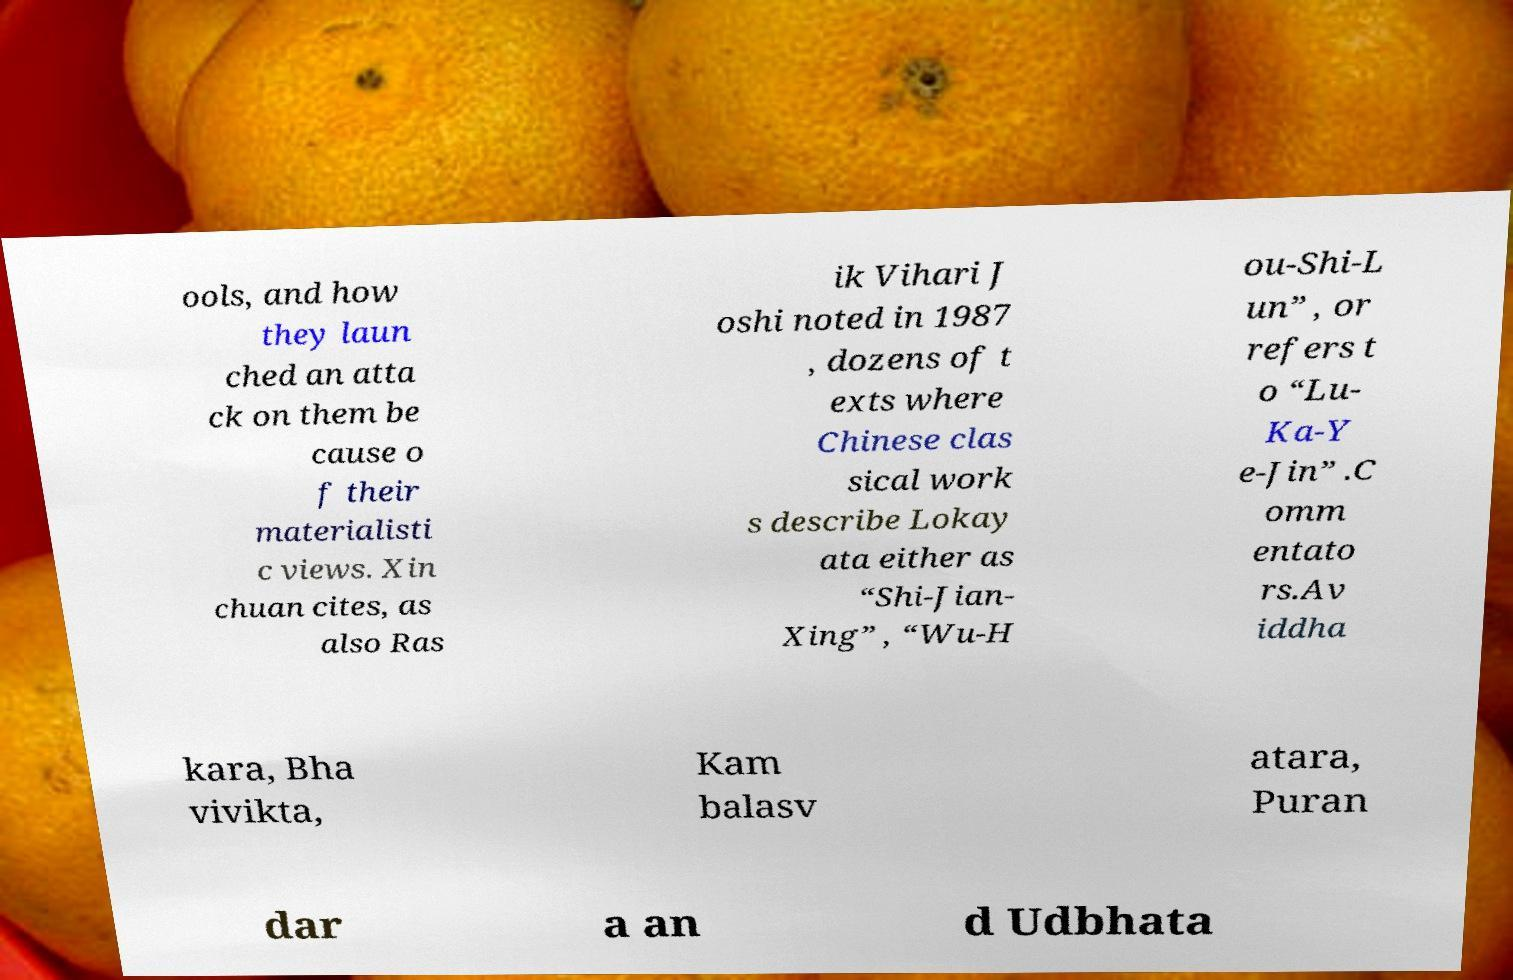What messages or text are displayed in this image? I need them in a readable, typed format. ools, and how they laun ched an atta ck on them be cause o f their materialisti c views. Xin chuan cites, as also Ras ik Vihari J oshi noted in 1987 , dozens of t exts where Chinese clas sical work s describe Lokay ata either as “Shi-Jian- Xing” , “Wu-H ou-Shi-L un” , or refers t o “Lu- Ka-Y e-Jin” .C omm entato rs.Av iddha kara, Bha vivikta, Kam balasv atara, Puran dar a an d Udbhata 